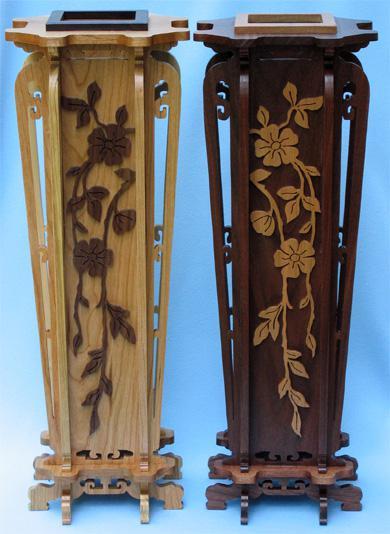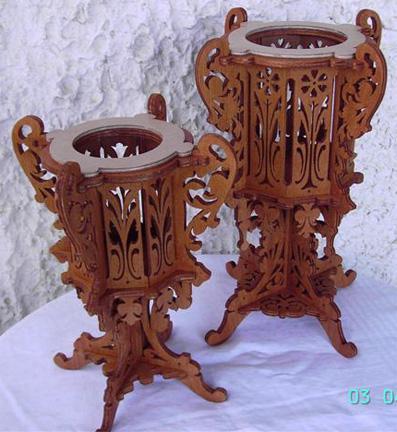The first image is the image on the left, the second image is the image on the right. Considering the images on both sides, is "Two wooden filigree stands, one larger than the other, have a cylindrical upper section with four handles, sitting on a base with four corresponding legs." valid? Answer yes or no. Yes. 